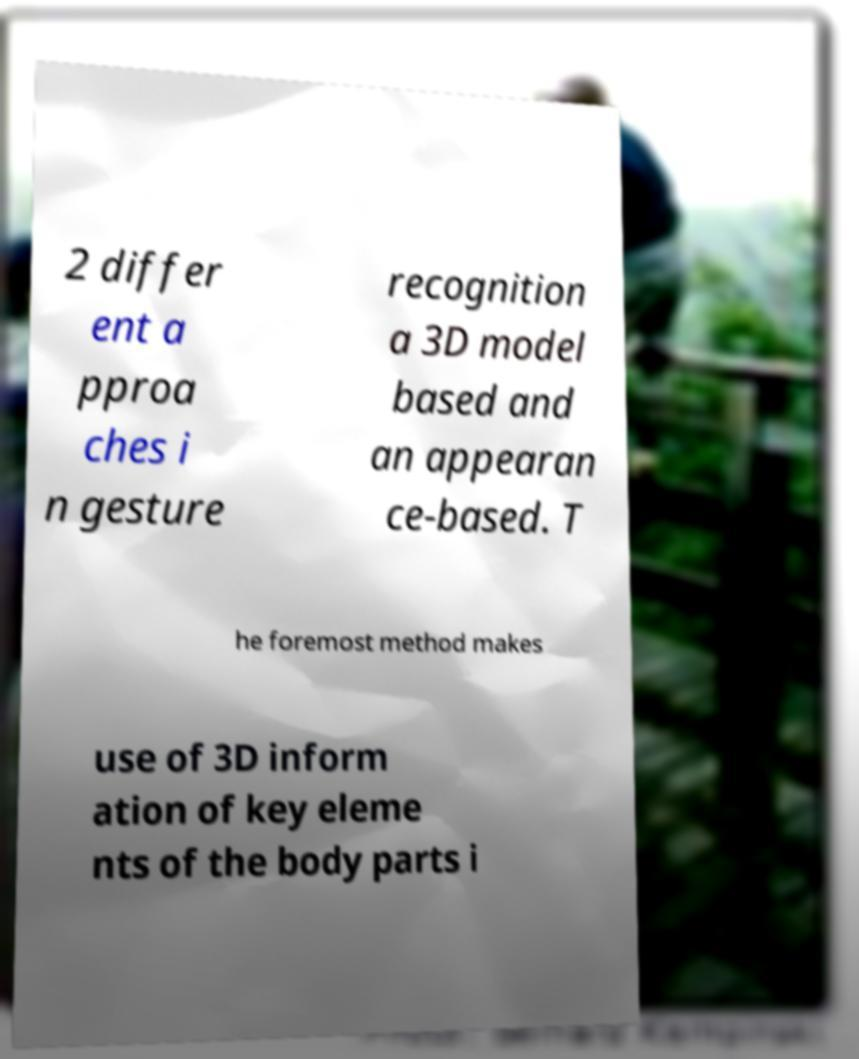Please read and relay the text visible in this image. What does it say? 2 differ ent a pproa ches i n gesture recognition a 3D model based and an appearan ce-based. T he foremost method makes use of 3D inform ation of key eleme nts of the body parts i 